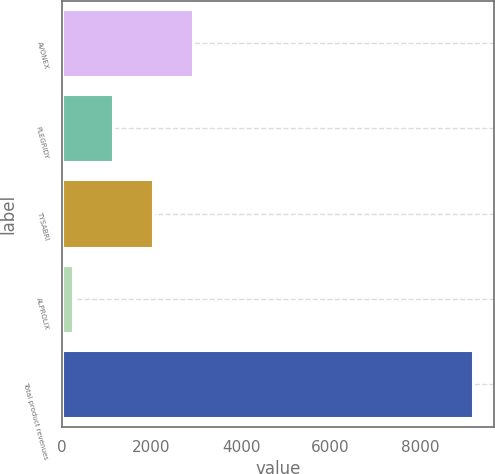Convert chart to OTSL. <chart><loc_0><loc_0><loc_500><loc_500><bar_chart><fcel>AVONEX<fcel>PLEGRIDY<fcel>TYSABRI<fcel>ALPROLIX<fcel>Total product revenues<nl><fcel>2920.7<fcel>1129.9<fcel>2025.3<fcel>234.5<fcel>9188.5<nl></chart> 